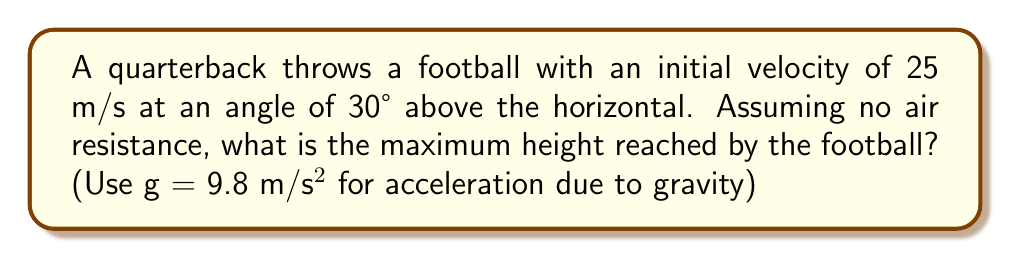Show me your answer to this math problem. Let's approach this step-by-step:

1) The vertical component of the initial velocity is given by:
   $v_y = v \sin \theta = 25 \cdot \sin 30° = 25 \cdot 0.5 = 12.5$ m/s

2) The time to reach the maximum height is when the vertical velocity becomes zero. We can use the equation:
   $v_y = v_0 - gt$
   
   Where $v_y = 0$ at the highest point, $v_0 = 12.5$ m/s, and $g = 9.8$ m/s²

3) Solving for $t$:
   $0 = 12.5 - 9.8t$
   $9.8t = 12.5$
   $t = \frac{12.5}{9.8} = 1.276$ seconds

4) Now, we can use the equation for displacement to find the maximum height:
   $y = v_0t - \frac{1}{2}gt^2$

5) Substituting our values:
   $y = 12.5 \cdot 1.276 - \frac{1}{2} \cdot 9.8 \cdot 1.276^2$
   $y = 15.95 - 7.975 = 7.975$ m

6) Therefore, the maximum height reached by the football is approximately 7.98 meters.
Answer: 7.98 m 